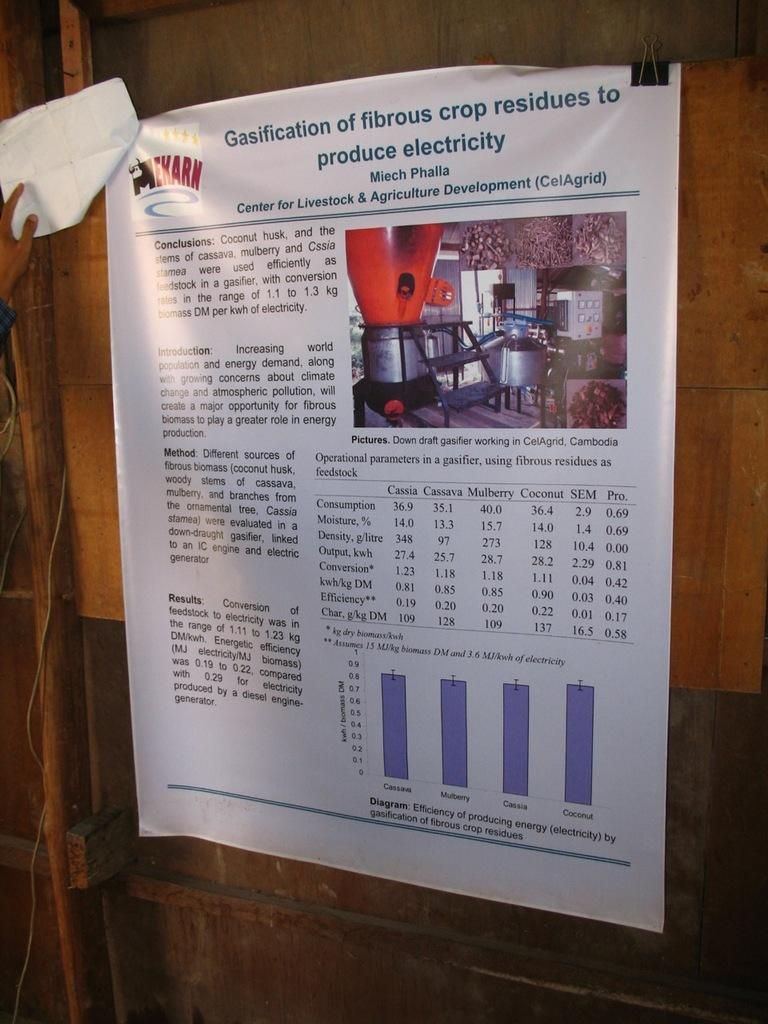<image>
Relay a brief, clear account of the picture shown. A gasification of fibrous crop residue information sheet form the Center for Livestock & Agriculture Development. 